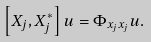Convert formula to latex. <formula><loc_0><loc_0><loc_500><loc_500>\left [ X _ { j } , X _ { j } ^ { \ast } \right ] u = \Phi _ { x _ { j } x _ { j } } u .</formula> 